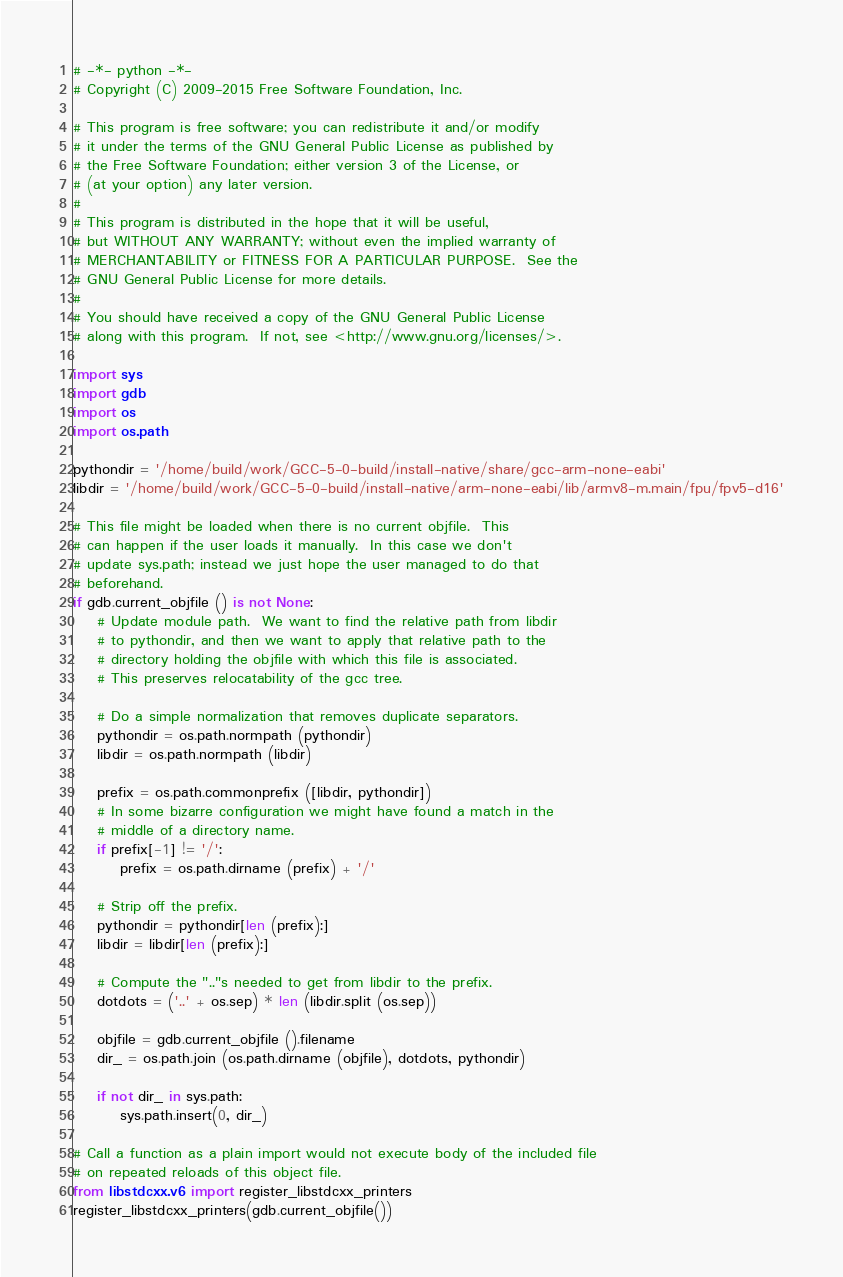<code> <loc_0><loc_0><loc_500><loc_500><_Python_># -*- python -*-
# Copyright (C) 2009-2015 Free Software Foundation, Inc.

# This program is free software; you can redistribute it and/or modify
# it under the terms of the GNU General Public License as published by
# the Free Software Foundation; either version 3 of the License, or
# (at your option) any later version.
#
# This program is distributed in the hope that it will be useful,
# but WITHOUT ANY WARRANTY; without even the implied warranty of
# MERCHANTABILITY or FITNESS FOR A PARTICULAR PURPOSE.  See the
# GNU General Public License for more details.
#
# You should have received a copy of the GNU General Public License
# along with this program.  If not, see <http://www.gnu.org/licenses/>.

import sys
import gdb
import os
import os.path

pythondir = '/home/build/work/GCC-5-0-build/install-native/share/gcc-arm-none-eabi'
libdir = '/home/build/work/GCC-5-0-build/install-native/arm-none-eabi/lib/armv8-m.main/fpu/fpv5-d16'

# This file might be loaded when there is no current objfile.  This
# can happen if the user loads it manually.  In this case we don't
# update sys.path; instead we just hope the user managed to do that
# beforehand.
if gdb.current_objfile () is not None:
    # Update module path.  We want to find the relative path from libdir
    # to pythondir, and then we want to apply that relative path to the
    # directory holding the objfile with which this file is associated.
    # This preserves relocatability of the gcc tree.

    # Do a simple normalization that removes duplicate separators.
    pythondir = os.path.normpath (pythondir)
    libdir = os.path.normpath (libdir)

    prefix = os.path.commonprefix ([libdir, pythondir])
    # In some bizarre configuration we might have found a match in the
    # middle of a directory name.
    if prefix[-1] != '/':
        prefix = os.path.dirname (prefix) + '/'

    # Strip off the prefix.
    pythondir = pythondir[len (prefix):]
    libdir = libdir[len (prefix):]

    # Compute the ".."s needed to get from libdir to the prefix.
    dotdots = ('..' + os.sep) * len (libdir.split (os.sep))

    objfile = gdb.current_objfile ().filename
    dir_ = os.path.join (os.path.dirname (objfile), dotdots, pythondir)

    if not dir_ in sys.path:
        sys.path.insert(0, dir_)

# Call a function as a plain import would not execute body of the included file
# on repeated reloads of this object file.
from libstdcxx.v6 import register_libstdcxx_printers
register_libstdcxx_printers(gdb.current_objfile())
</code> 